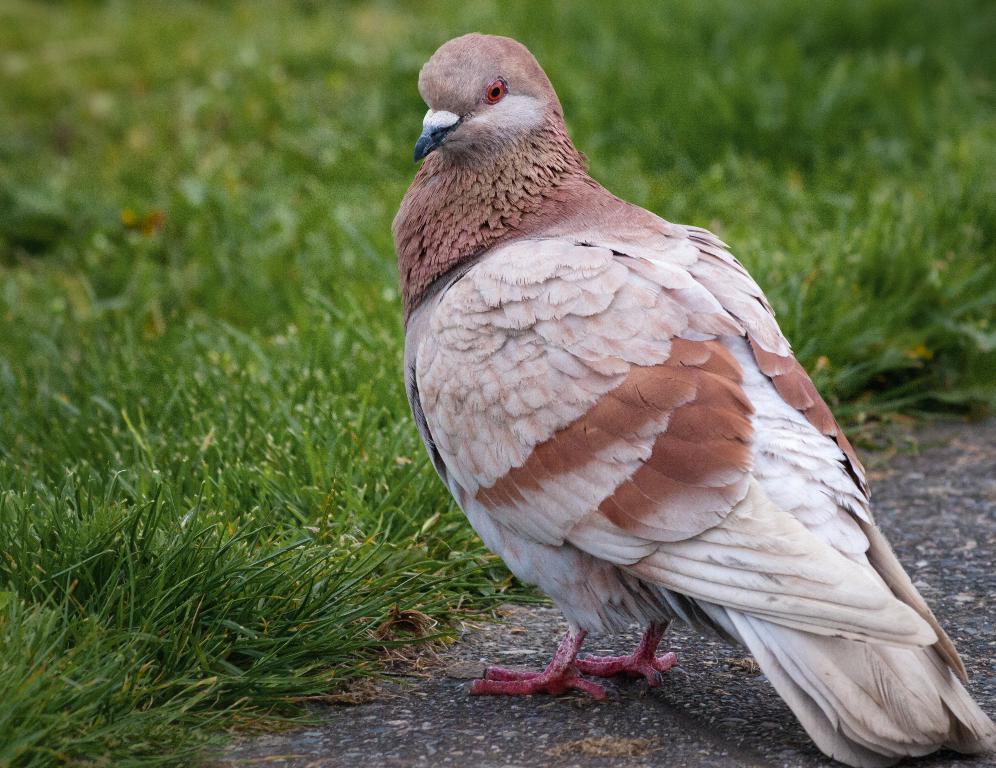Describe this image in one or two sentences. In this image I can see a bird visible in front of crop. 